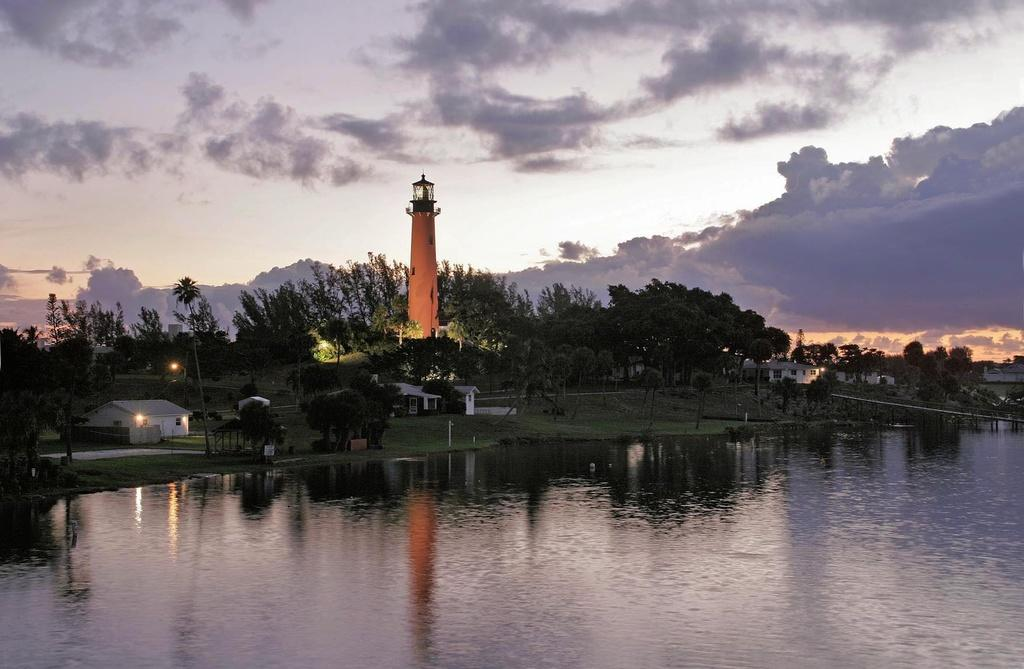What is the primary element visible in the image? There is water in the image. What type of natural vegetation can be seen in the image? There are trees in the image. What type of man-made structures are present in the image? There are buildings and a lighthouse in the image. What is visible at the top of the image? The sky is visible at the top of the image. Can you see any feathers floating on the water in the image? There are no feathers visible in the image. Is there a turkey present in the image? There is no turkey present in the image. 